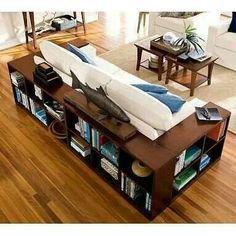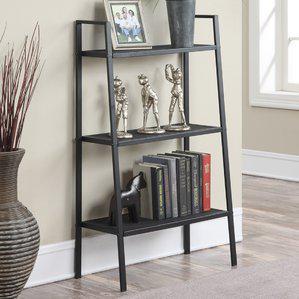The first image is the image on the left, the second image is the image on the right. Examine the images to the left and right. Is the description "An image shows a sofa with neutral ecru cushions and bookshelves built into the sides." accurate? Answer yes or no. Yes. The first image is the image on the left, the second image is the image on the right. For the images shown, is this caption "A black bookshelf sits against the wall in one of the images." true? Answer yes or no. Yes. 